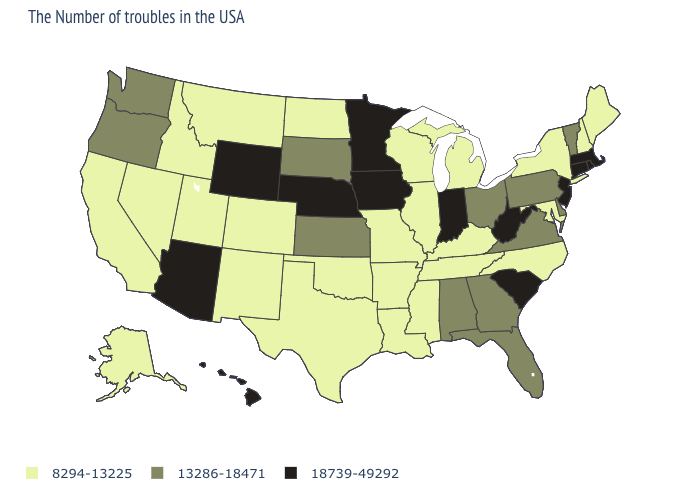What is the lowest value in states that border Oregon?
Concise answer only. 8294-13225. Name the states that have a value in the range 8294-13225?
Keep it brief. Maine, New Hampshire, New York, Maryland, North Carolina, Michigan, Kentucky, Tennessee, Wisconsin, Illinois, Mississippi, Louisiana, Missouri, Arkansas, Oklahoma, Texas, North Dakota, Colorado, New Mexico, Utah, Montana, Idaho, Nevada, California, Alaska. Among the states that border South Carolina , which have the highest value?
Concise answer only. Georgia. Among the states that border New York , which have the highest value?
Quick response, please. Massachusetts, Connecticut, New Jersey. What is the value of South Dakota?
Give a very brief answer. 13286-18471. Does New Hampshire have the highest value in the USA?
Concise answer only. No. Name the states that have a value in the range 8294-13225?
Be succinct. Maine, New Hampshire, New York, Maryland, North Carolina, Michigan, Kentucky, Tennessee, Wisconsin, Illinois, Mississippi, Louisiana, Missouri, Arkansas, Oklahoma, Texas, North Dakota, Colorado, New Mexico, Utah, Montana, Idaho, Nevada, California, Alaska. What is the value of Delaware?
Write a very short answer. 13286-18471. What is the value of Kansas?
Be succinct. 13286-18471. Does the first symbol in the legend represent the smallest category?
Write a very short answer. Yes. Which states have the lowest value in the MidWest?
Keep it brief. Michigan, Wisconsin, Illinois, Missouri, North Dakota. What is the value of Connecticut?
Give a very brief answer. 18739-49292. Does the map have missing data?
Be succinct. No. What is the value of Massachusetts?
Concise answer only. 18739-49292. What is the value of South Carolina?
Short answer required. 18739-49292. 